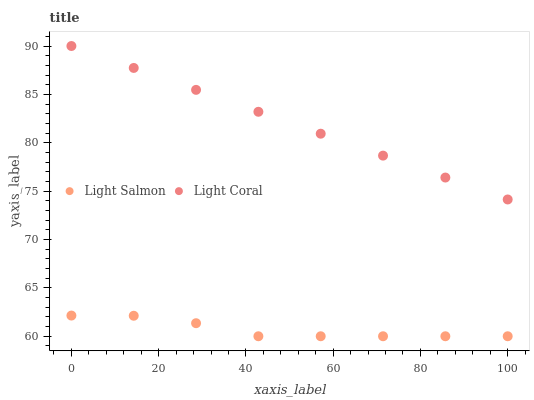Does Light Salmon have the minimum area under the curve?
Answer yes or no. Yes. Does Light Coral have the maximum area under the curve?
Answer yes or no. Yes. Does Light Salmon have the maximum area under the curve?
Answer yes or no. No. Is Light Coral the smoothest?
Answer yes or no. Yes. Is Light Salmon the roughest?
Answer yes or no. Yes. Is Light Salmon the smoothest?
Answer yes or no. No. Does Light Salmon have the lowest value?
Answer yes or no. Yes. Does Light Coral have the highest value?
Answer yes or no. Yes. Does Light Salmon have the highest value?
Answer yes or no. No. Is Light Salmon less than Light Coral?
Answer yes or no. Yes. Is Light Coral greater than Light Salmon?
Answer yes or no. Yes. Does Light Salmon intersect Light Coral?
Answer yes or no. No. 